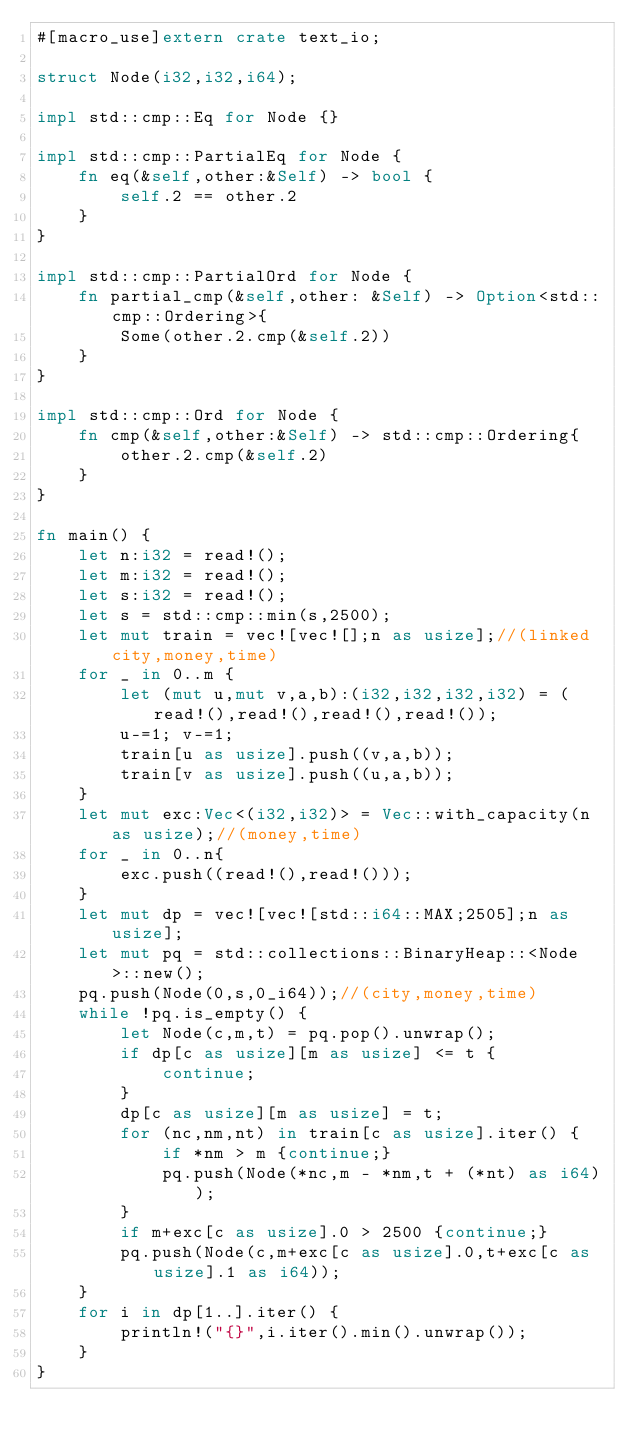<code> <loc_0><loc_0><loc_500><loc_500><_Rust_>#[macro_use]extern crate text_io;

struct Node(i32,i32,i64);

impl std::cmp::Eq for Node {}

impl std::cmp::PartialEq for Node {
    fn eq(&self,other:&Self) -> bool {
        self.2 == other.2
    }
}

impl std::cmp::PartialOrd for Node {
    fn partial_cmp(&self,other: &Self) -> Option<std::cmp::Ordering>{
        Some(other.2.cmp(&self.2))
    }
} 

impl std::cmp::Ord for Node {
    fn cmp(&self,other:&Self) -> std::cmp::Ordering{
        other.2.cmp(&self.2)
    }
}

fn main() {
    let n:i32 = read!();
    let m:i32 = read!();
    let s:i32 = read!();
    let s = std::cmp::min(s,2500);
    let mut train = vec![vec![];n as usize];//(linked city,money,time)
    for _ in 0..m {
        let (mut u,mut v,a,b):(i32,i32,i32,i32) = (read!(),read!(),read!(),read!());
        u-=1; v-=1;
        train[u as usize].push((v,a,b));
        train[v as usize].push((u,a,b));
    }
    let mut exc:Vec<(i32,i32)> = Vec::with_capacity(n as usize);//(money,time)
    for _ in 0..n{
        exc.push((read!(),read!()));
    }
    let mut dp = vec![vec![std::i64::MAX;2505];n as usize];
    let mut pq = std::collections::BinaryHeap::<Node>::new();
    pq.push(Node(0,s,0_i64));//(city,money,time)
    while !pq.is_empty() {
        let Node(c,m,t) = pq.pop().unwrap();
        if dp[c as usize][m as usize] <= t {
            continue;
        }
        dp[c as usize][m as usize] = t;
        for (nc,nm,nt) in train[c as usize].iter() {
            if *nm > m {continue;}
            pq.push(Node(*nc,m - *nm,t + (*nt) as i64));
        }
        if m+exc[c as usize].0 > 2500 {continue;}
        pq.push(Node(c,m+exc[c as usize].0,t+exc[c as usize].1 as i64));
    }
    for i in dp[1..].iter() {
        println!("{}",i.iter().min().unwrap());
    }
}</code> 